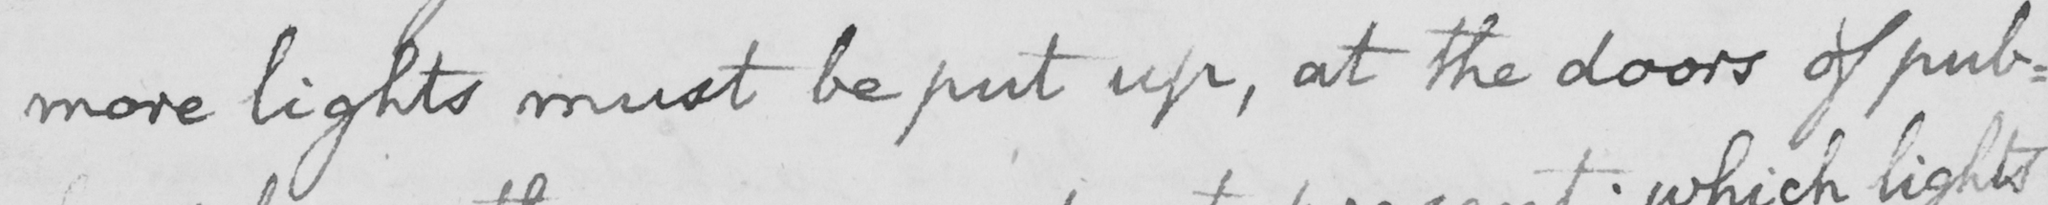What is written in this line of handwriting? more lights must be put up , at the doors of pub : 